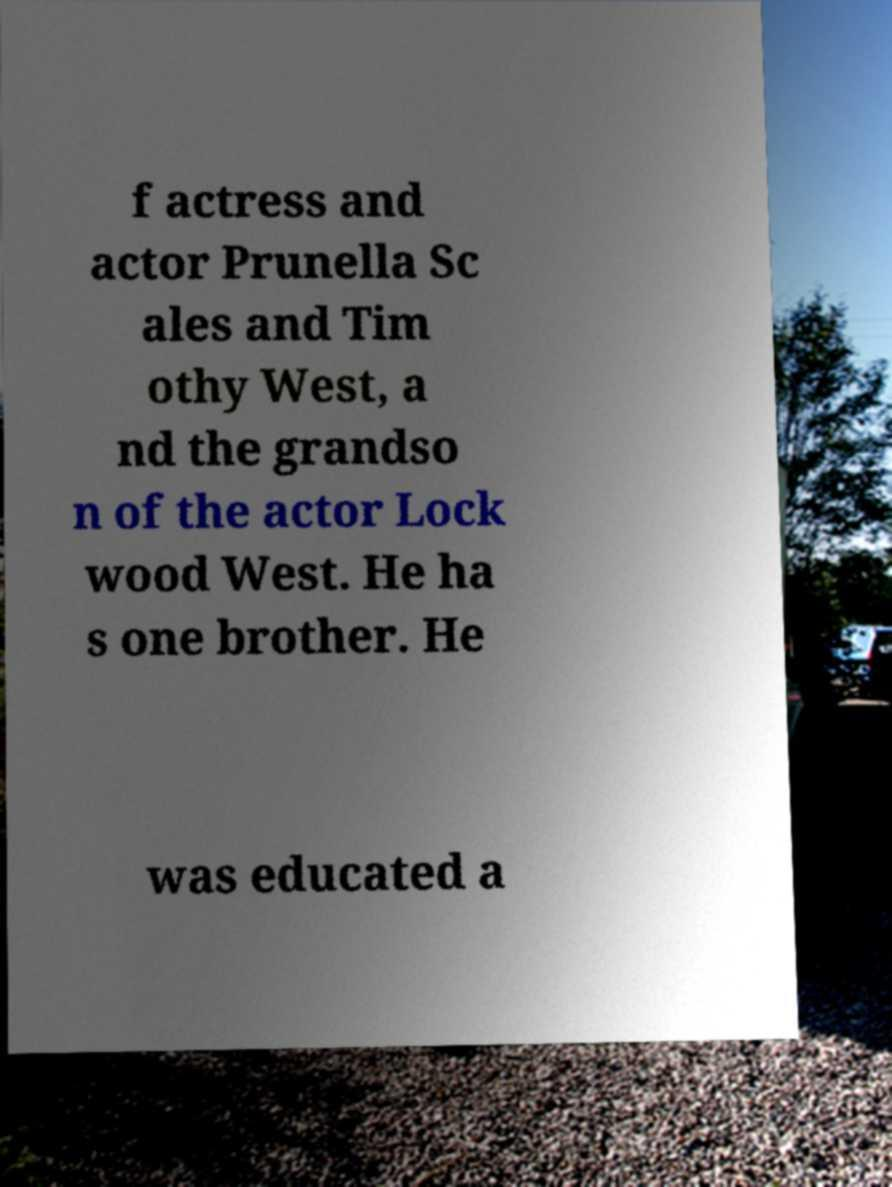Please read and relay the text visible in this image. What does it say? f actress and actor Prunella Sc ales and Tim othy West, a nd the grandso n of the actor Lock wood West. He ha s one brother. He was educated a 